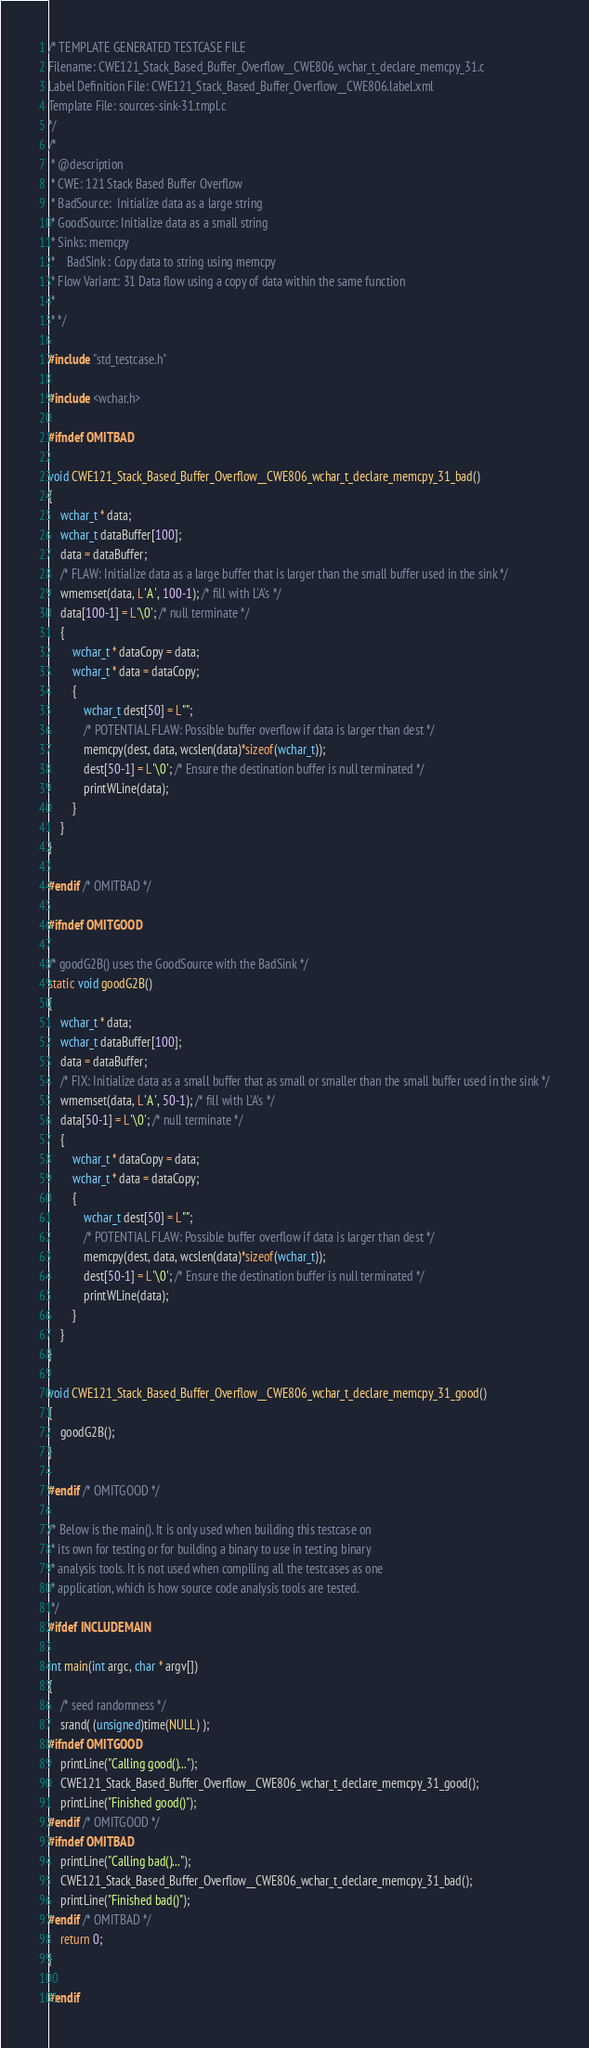<code> <loc_0><loc_0><loc_500><loc_500><_C_>/* TEMPLATE GENERATED TESTCASE FILE
Filename: CWE121_Stack_Based_Buffer_Overflow__CWE806_wchar_t_declare_memcpy_31.c
Label Definition File: CWE121_Stack_Based_Buffer_Overflow__CWE806.label.xml
Template File: sources-sink-31.tmpl.c
*/
/*
 * @description
 * CWE: 121 Stack Based Buffer Overflow
 * BadSource:  Initialize data as a large string
 * GoodSource: Initialize data as a small string
 * Sinks: memcpy
 *    BadSink : Copy data to string using memcpy
 * Flow Variant: 31 Data flow using a copy of data within the same function
 *
 * */

#include "std_testcase.h"

#include <wchar.h>

#ifndef OMITBAD

void CWE121_Stack_Based_Buffer_Overflow__CWE806_wchar_t_declare_memcpy_31_bad()
{
    wchar_t * data;
    wchar_t dataBuffer[100];
    data = dataBuffer;
    /* FLAW: Initialize data as a large buffer that is larger than the small buffer used in the sink */
    wmemset(data, L'A', 100-1); /* fill with L'A's */
    data[100-1] = L'\0'; /* null terminate */
    {
        wchar_t * dataCopy = data;
        wchar_t * data = dataCopy;
        {
            wchar_t dest[50] = L"";
            /* POTENTIAL FLAW: Possible buffer overflow if data is larger than dest */
            memcpy(dest, data, wcslen(data)*sizeof(wchar_t));
            dest[50-1] = L'\0'; /* Ensure the destination buffer is null terminated */
            printWLine(data);
        }
    }
}

#endif /* OMITBAD */

#ifndef OMITGOOD

/* goodG2B() uses the GoodSource with the BadSink */
static void goodG2B()
{
    wchar_t * data;
    wchar_t dataBuffer[100];
    data = dataBuffer;
    /* FIX: Initialize data as a small buffer that as small or smaller than the small buffer used in the sink */
    wmemset(data, L'A', 50-1); /* fill with L'A's */
    data[50-1] = L'\0'; /* null terminate */
    {
        wchar_t * dataCopy = data;
        wchar_t * data = dataCopy;
        {
            wchar_t dest[50] = L"";
            /* POTENTIAL FLAW: Possible buffer overflow if data is larger than dest */
            memcpy(dest, data, wcslen(data)*sizeof(wchar_t));
            dest[50-1] = L'\0'; /* Ensure the destination buffer is null terminated */
            printWLine(data);
        }
    }
}

void CWE121_Stack_Based_Buffer_Overflow__CWE806_wchar_t_declare_memcpy_31_good()
{
    goodG2B();
}

#endif /* OMITGOOD */

/* Below is the main(). It is only used when building this testcase on
 * its own for testing or for building a binary to use in testing binary
 * analysis tools. It is not used when compiling all the testcases as one
 * application, which is how source code analysis tools are tested.
 */
#ifdef INCLUDEMAIN

int main(int argc, char * argv[])
{
    /* seed randomness */
    srand( (unsigned)time(NULL) );
#ifndef OMITGOOD
    printLine("Calling good()...");
    CWE121_Stack_Based_Buffer_Overflow__CWE806_wchar_t_declare_memcpy_31_good();
    printLine("Finished good()");
#endif /* OMITGOOD */
#ifndef OMITBAD
    printLine("Calling bad()...");
    CWE121_Stack_Based_Buffer_Overflow__CWE806_wchar_t_declare_memcpy_31_bad();
    printLine("Finished bad()");
#endif /* OMITBAD */
    return 0;
}

#endif
</code> 